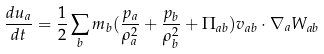<formula> <loc_0><loc_0><loc_500><loc_500>\frac { d u _ { a } } { d t } = \frac { 1 } { 2 } \sum _ { b } m _ { b } ( \frac { p _ { a } } { \rho _ { a } ^ { 2 } } + \frac { p _ { b } } { \rho _ { b } ^ { 2 } } + \Pi _ { a b } ) v _ { a b } \cdot \nabla _ { a } W _ { a b }</formula> 